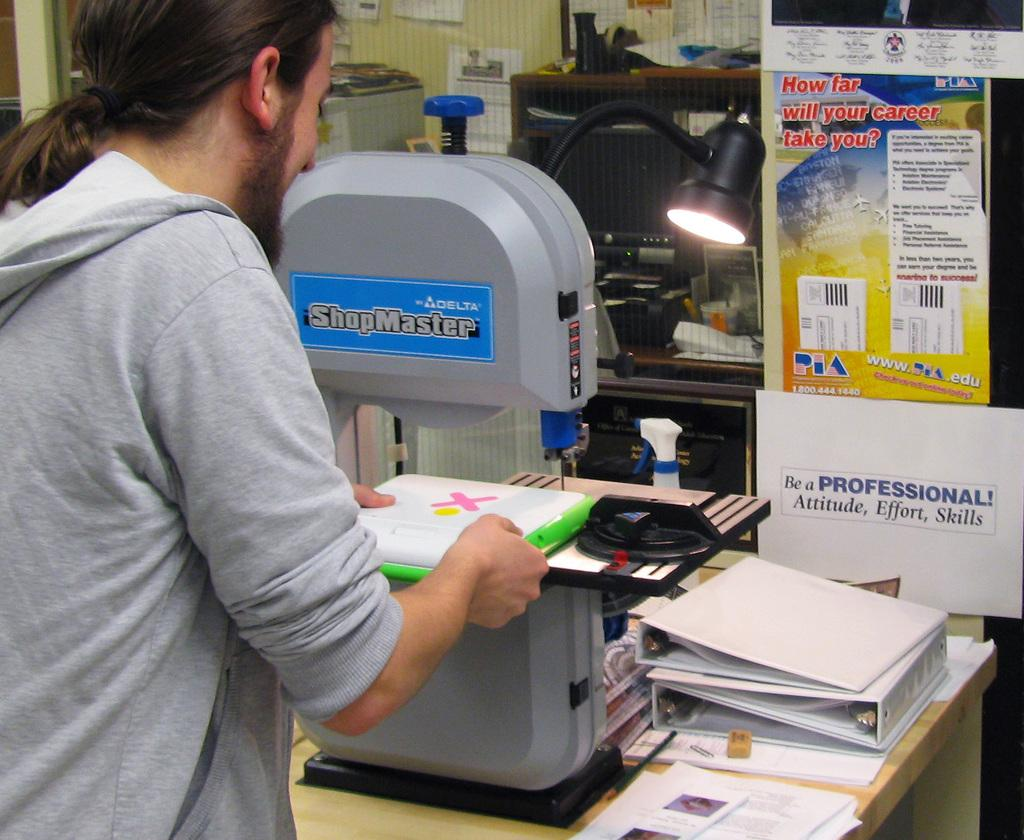<image>
Provide a brief description of the given image. A man works on a Shopmaster piece of equipment. 